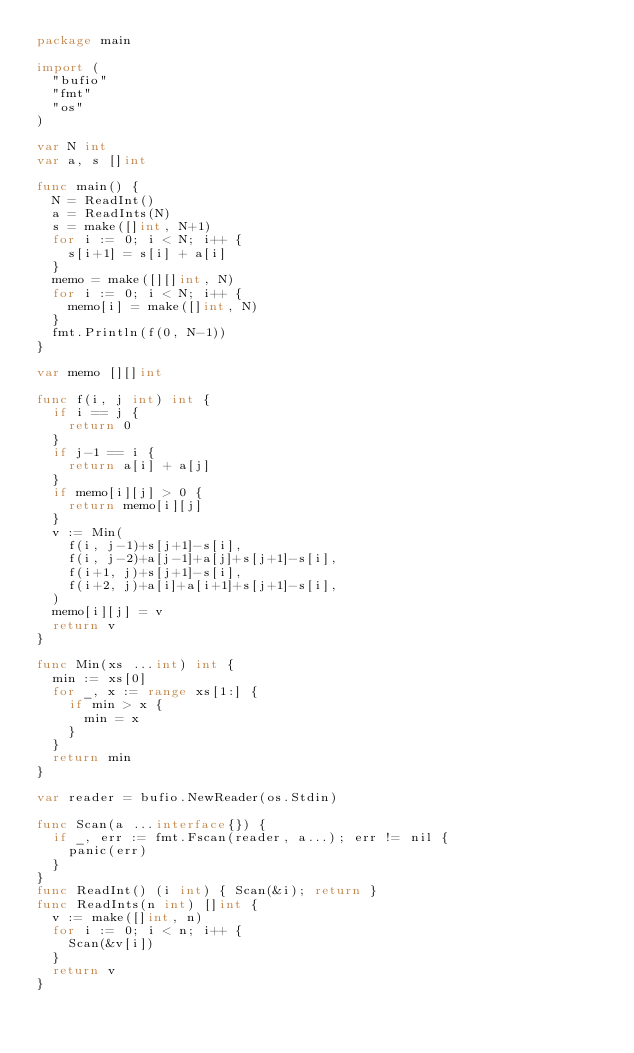Convert code to text. <code><loc_0><loc_0><loc_500><loc_500><_Go_>package main

import (
	"bufio"
	"fmt"
	"os"
)

var N int
var a, s []int

func main() {
	N = ReadInt()
	a = ReadInts(N)
	s = make([]int, N+1)
	for i := 0; i < N; i++ {
		s[i+1] = s[i] + a[i]
	}
	memo = make([][]int, N)
	for i := 0; i < N; i++ {
		memo[i] = make([]int, N)
	}
	fmt.Println(f(0, N-1))
}

var memo [][]int

func f(i, j int) int {
	if i == j {
		return 0
	}
	if j-1 == i {
		return a[i] + a[j]
	}
	if memo[i][j] > 0 {
		return memo[i][j]
	}
	v := Min(
		f(i, j-1)+s[j+1]-s[i],
		f(i, j-2)+a[j-1]+a[j]+s[j+1]-s[i],
		f(i+1, j)+s[j+1]-s[i],
		f(i+2, j)+a[i]+a[i+1]+s[j+1]-s[i],
	)
	memo[i][j] = v
	return v
}

func Min(xs ...int) int {
	min := xs[0]
	for _, x := range xs[1:] {
		if min > x {
			min = x
		}
	}
	return min
}

var reader = bufio.NewReader(os.Stdin)

func Scan(a ...interface{}) {
	if _, err := fmt.Fscan(reader, a...); err != nil {
		panic(err)
	}
}
func ReadInt() (i int) { Scan(&i); return }
func ReadInts(n int) []int {
	v := make([]int, n)
	for i := 0; i < n; i++ {
		Scan(&v[i])
	}
	return v
}
</code> 